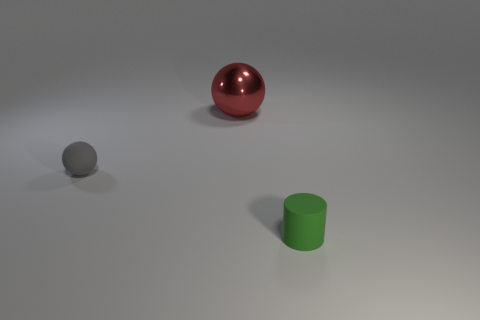What size is the green cylinder that is the same material as the tiny gray sphere?
Provide a succinct answer. Small. Are there more green things that are left of the green matte cylinder than big red balls?
Make the answer very short. No. What is the size of the object that is left of the green cylinder and on the right side of the tiny rubber ball?
Give a very brief answer. Large. What material is the small object that is the same shape as the large shiny thing?
Your answer should be compact. Rubber. There is a rubber thing behind the matte cylinder; is its size the same as the red metal object?
Offer a terse response. No. What is the color of the object that is both in front of the metal thing and on the right side of the small gray thing?
Your answer should be very brief. Green. What number of objects are in front of the small thing on the left side of the shiny ball?
Your response must be concise. 1. Is the shape of the shiny object the same as the tiny green object?
Your answer should be very brief. No. Are there any other things that have the same color as the shiny sphere?
Keep it short and to the point. No. Do the red shiny thing and the matte thing that is on the left side of the tiny cylinder have the same shape?
Provide a succinct answer. Yes. 